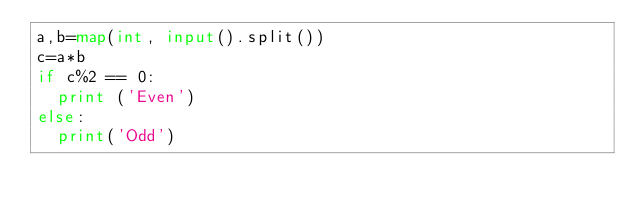<code> <loc_0><loc_0><loc_500><loc_500><_Python_>a,b=map(int, input().split())
c=a*b
if c%2 == 0:
  print ('Even')
else:
  print('Odd')
    </code> 